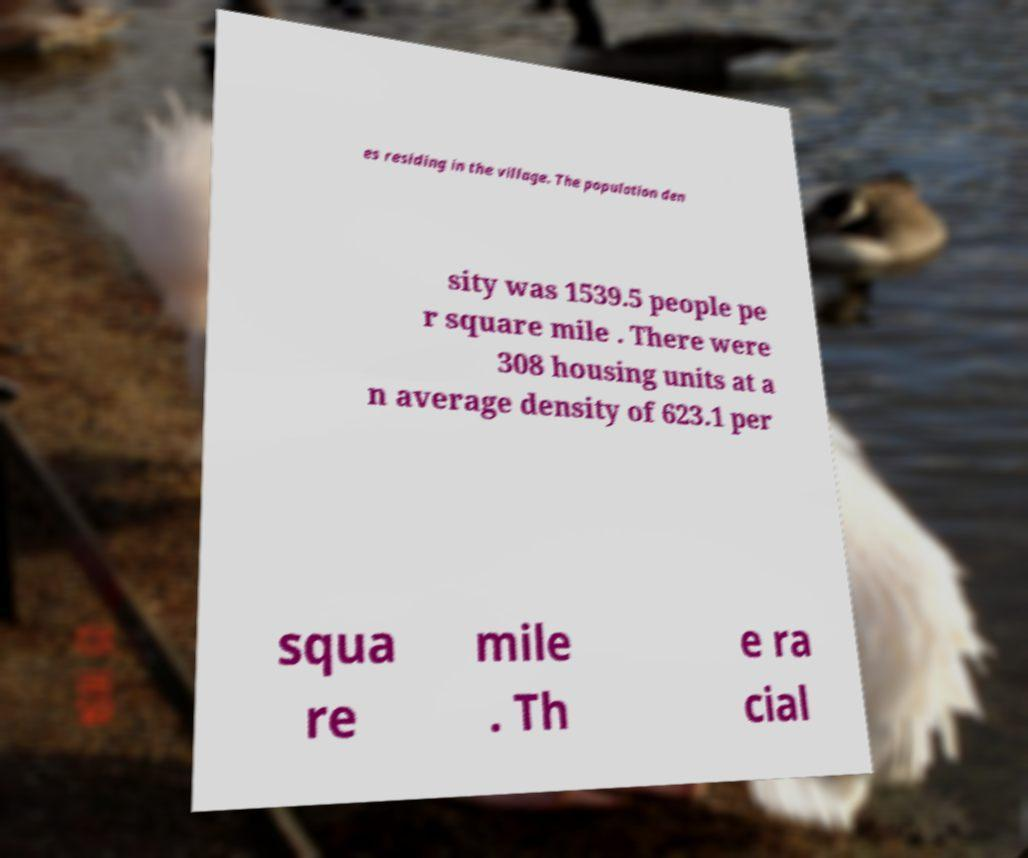Can you accurately transcribe the text from the provided image for me? es residing in the village. The population den sity was 1539.5 people pe r square mile . There were 308 housing units at a n average density of 623.1 per squa re mile . Th e ra cial 